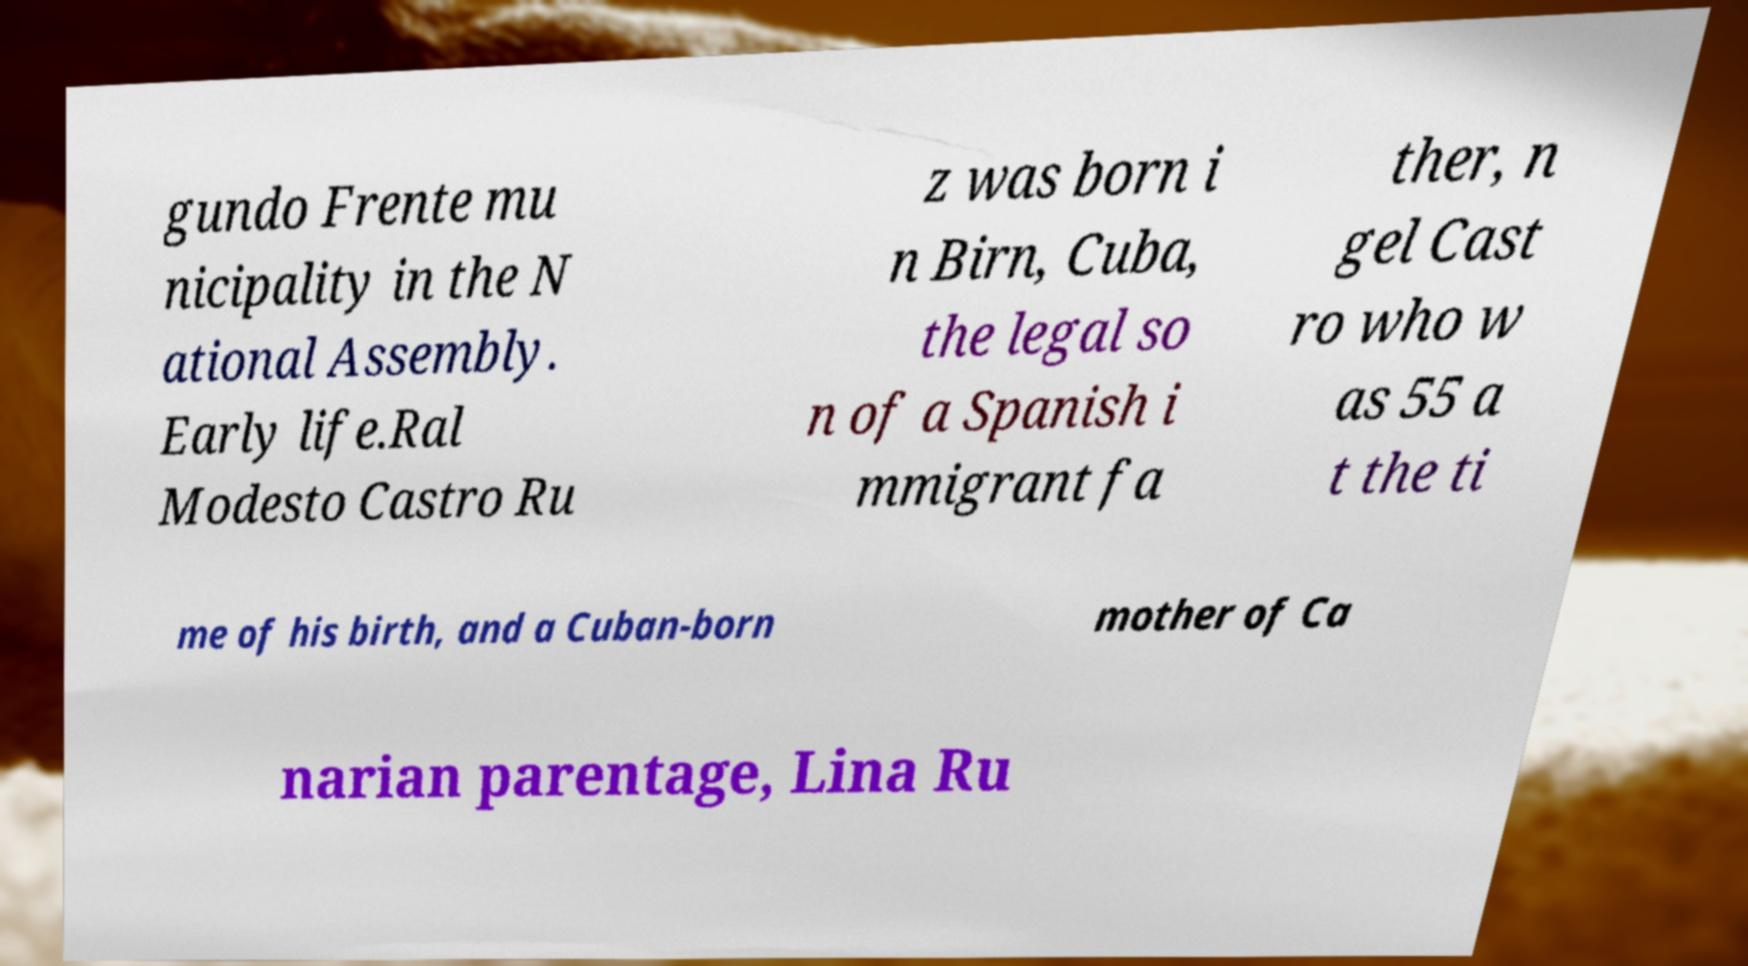Please identify and transcribe the text found in this image. gundo Frente mu nicipality in the N ational Assembly. Early life.Ral Modesto Castro Ru z was born i n Birn, Cuba, the legal so n of a Spanish i mmigrant fa ther, n gel Cast ro who w as 55 a t the ti me of his birth, and a Cuban-born mother of Ca narian parentage, Lina Ru 